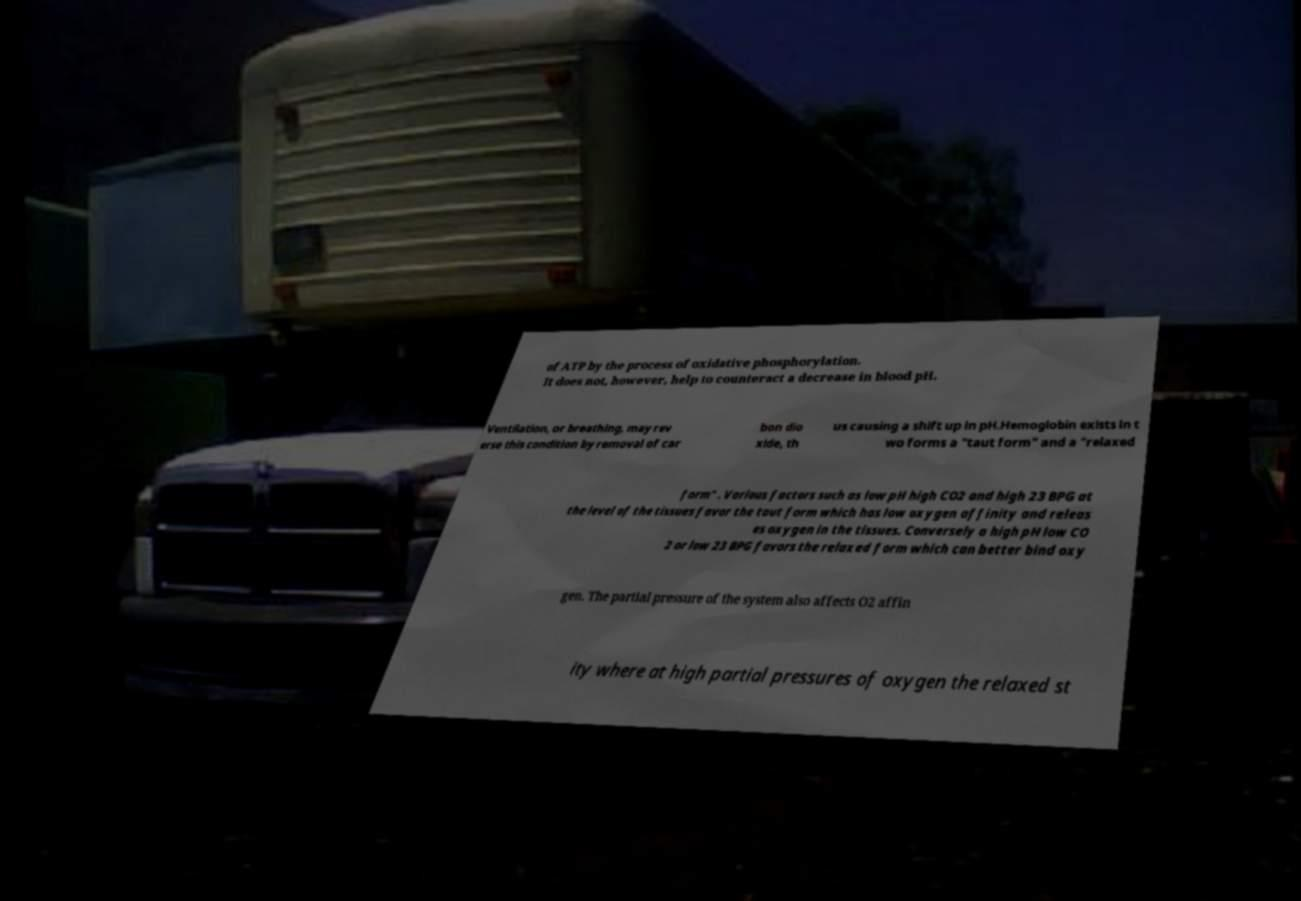Please identify and transcribe the text found in this image. of ATP by the process of oxidative phosphorylation. It does not, however, help to counteract a decrease in blood pH. Ventilation, or breathing, may rev erse this condition by removal of car bon dio xide, th us causing a shift up in pH.Hemoglobin exists in t wo forms a "taut form" and a "relaxed form" . Various factors such as low pH high CO2 and high 23 BPG at the level of the tissues favor the taut form which has low oxygen affinity and releas es oxygen in the tissues. Conversely a high pH low CO 2 or low 23 BPG favors the relaxed form which can better bind oxy gen. The partial pressure of the system also affects O2 affin ity where at high partial pressures of oxygen the relaxed st 